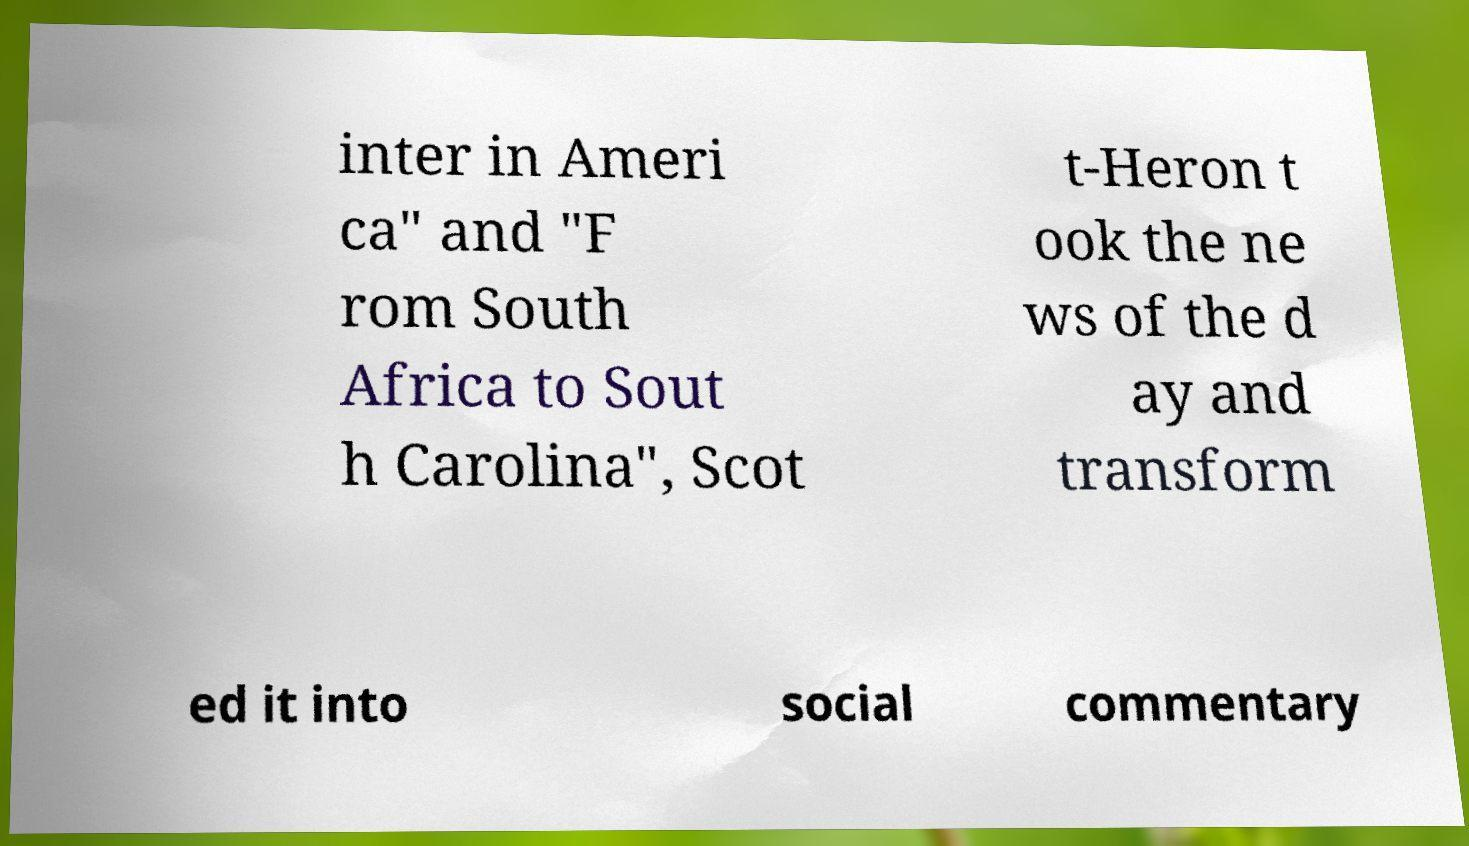There's text embedded in this image that I need extracted. Can you transcribe it verbatim? inter in Ameri ca" and "F rom South Africa to Sout h Carolina", Scot t-Heron t ook the ne ws of the d ay and transform ed it into social commentary 